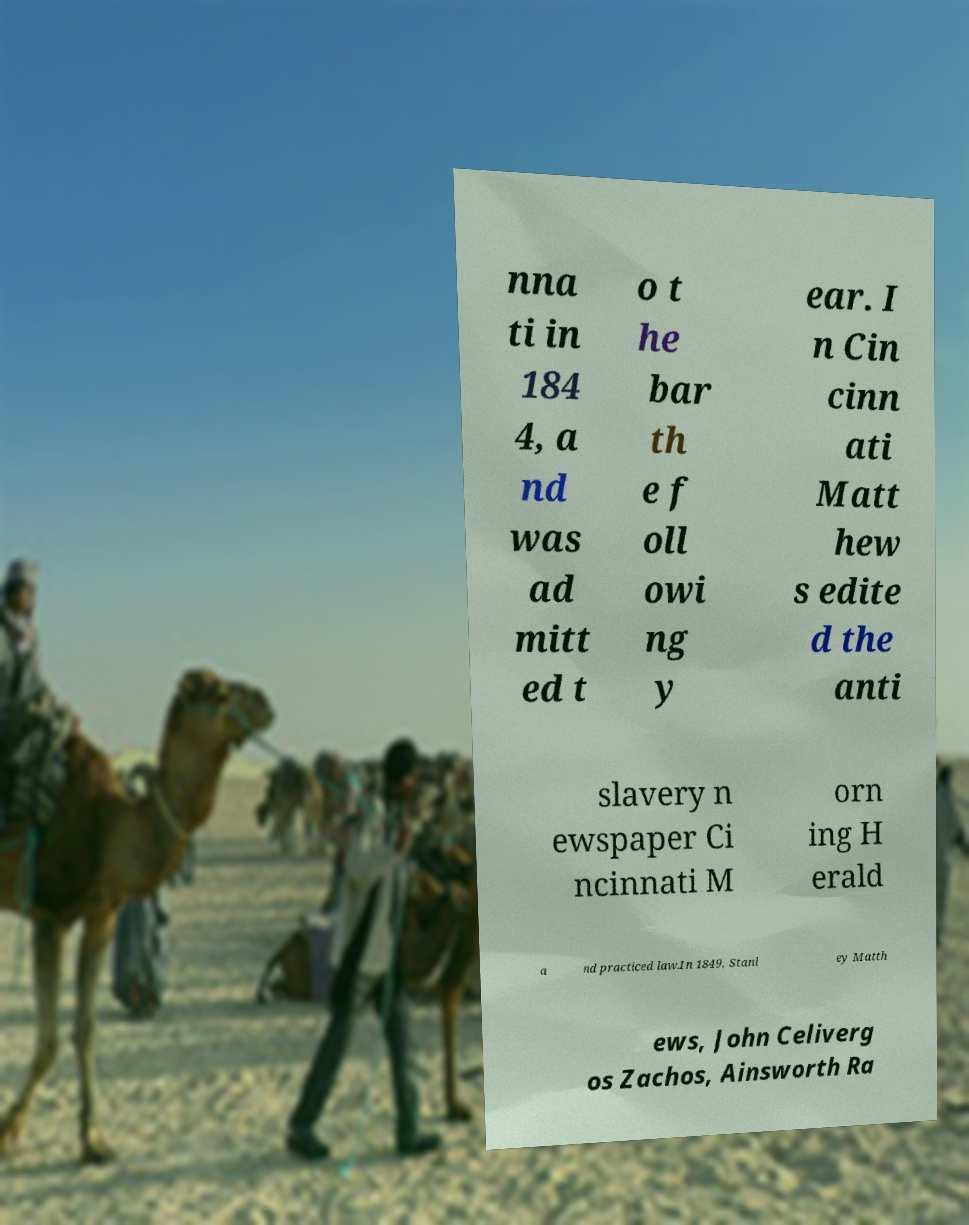Please read and relay the text visible in this image. What does it say? nna ti in 184 4, a nd was ad mitt ed t o t he bar th e f oll owi ng y ear. I n Cin cinn ati Matt hew s edite d the anti slavery n ewspaper Ci ncinnati M orn ing H erald a nd practiced law.In 1849, Stanl ey Matth ews, John Celiverg os Zachos, Ainsworth Ra 